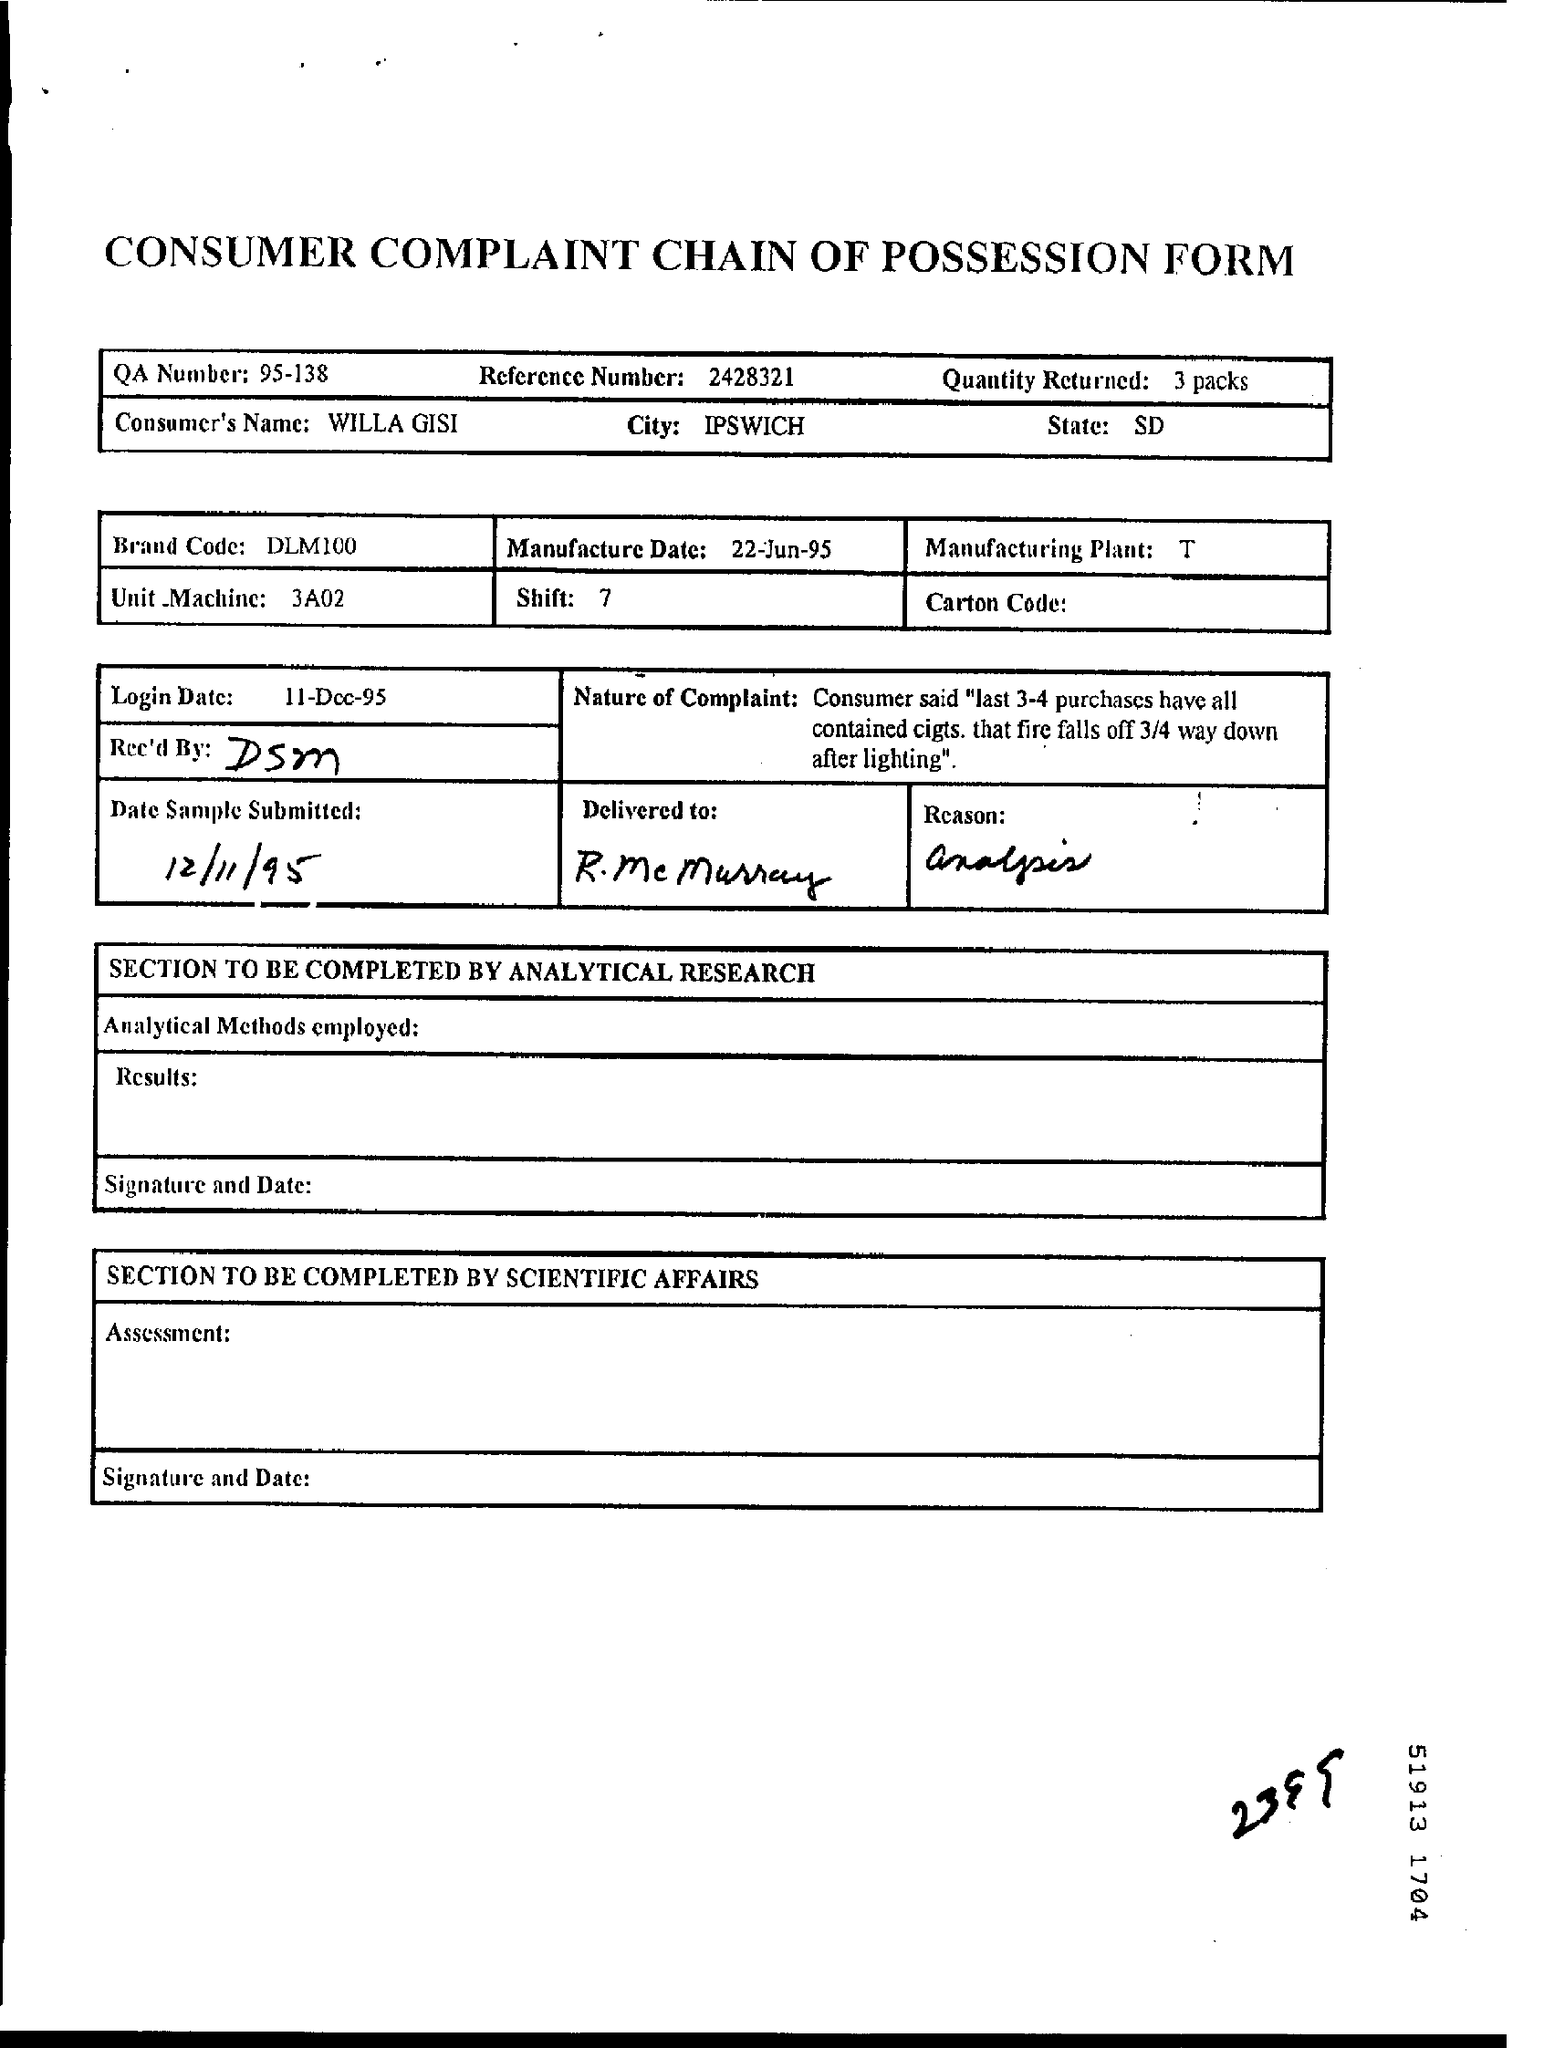Specify some key components in this picture. I received 3 packs in total. The QA number is 95-138. The state whose name is SD has not been identified. The brand code is DLM100. The manufacture date is June 22, 1995. 